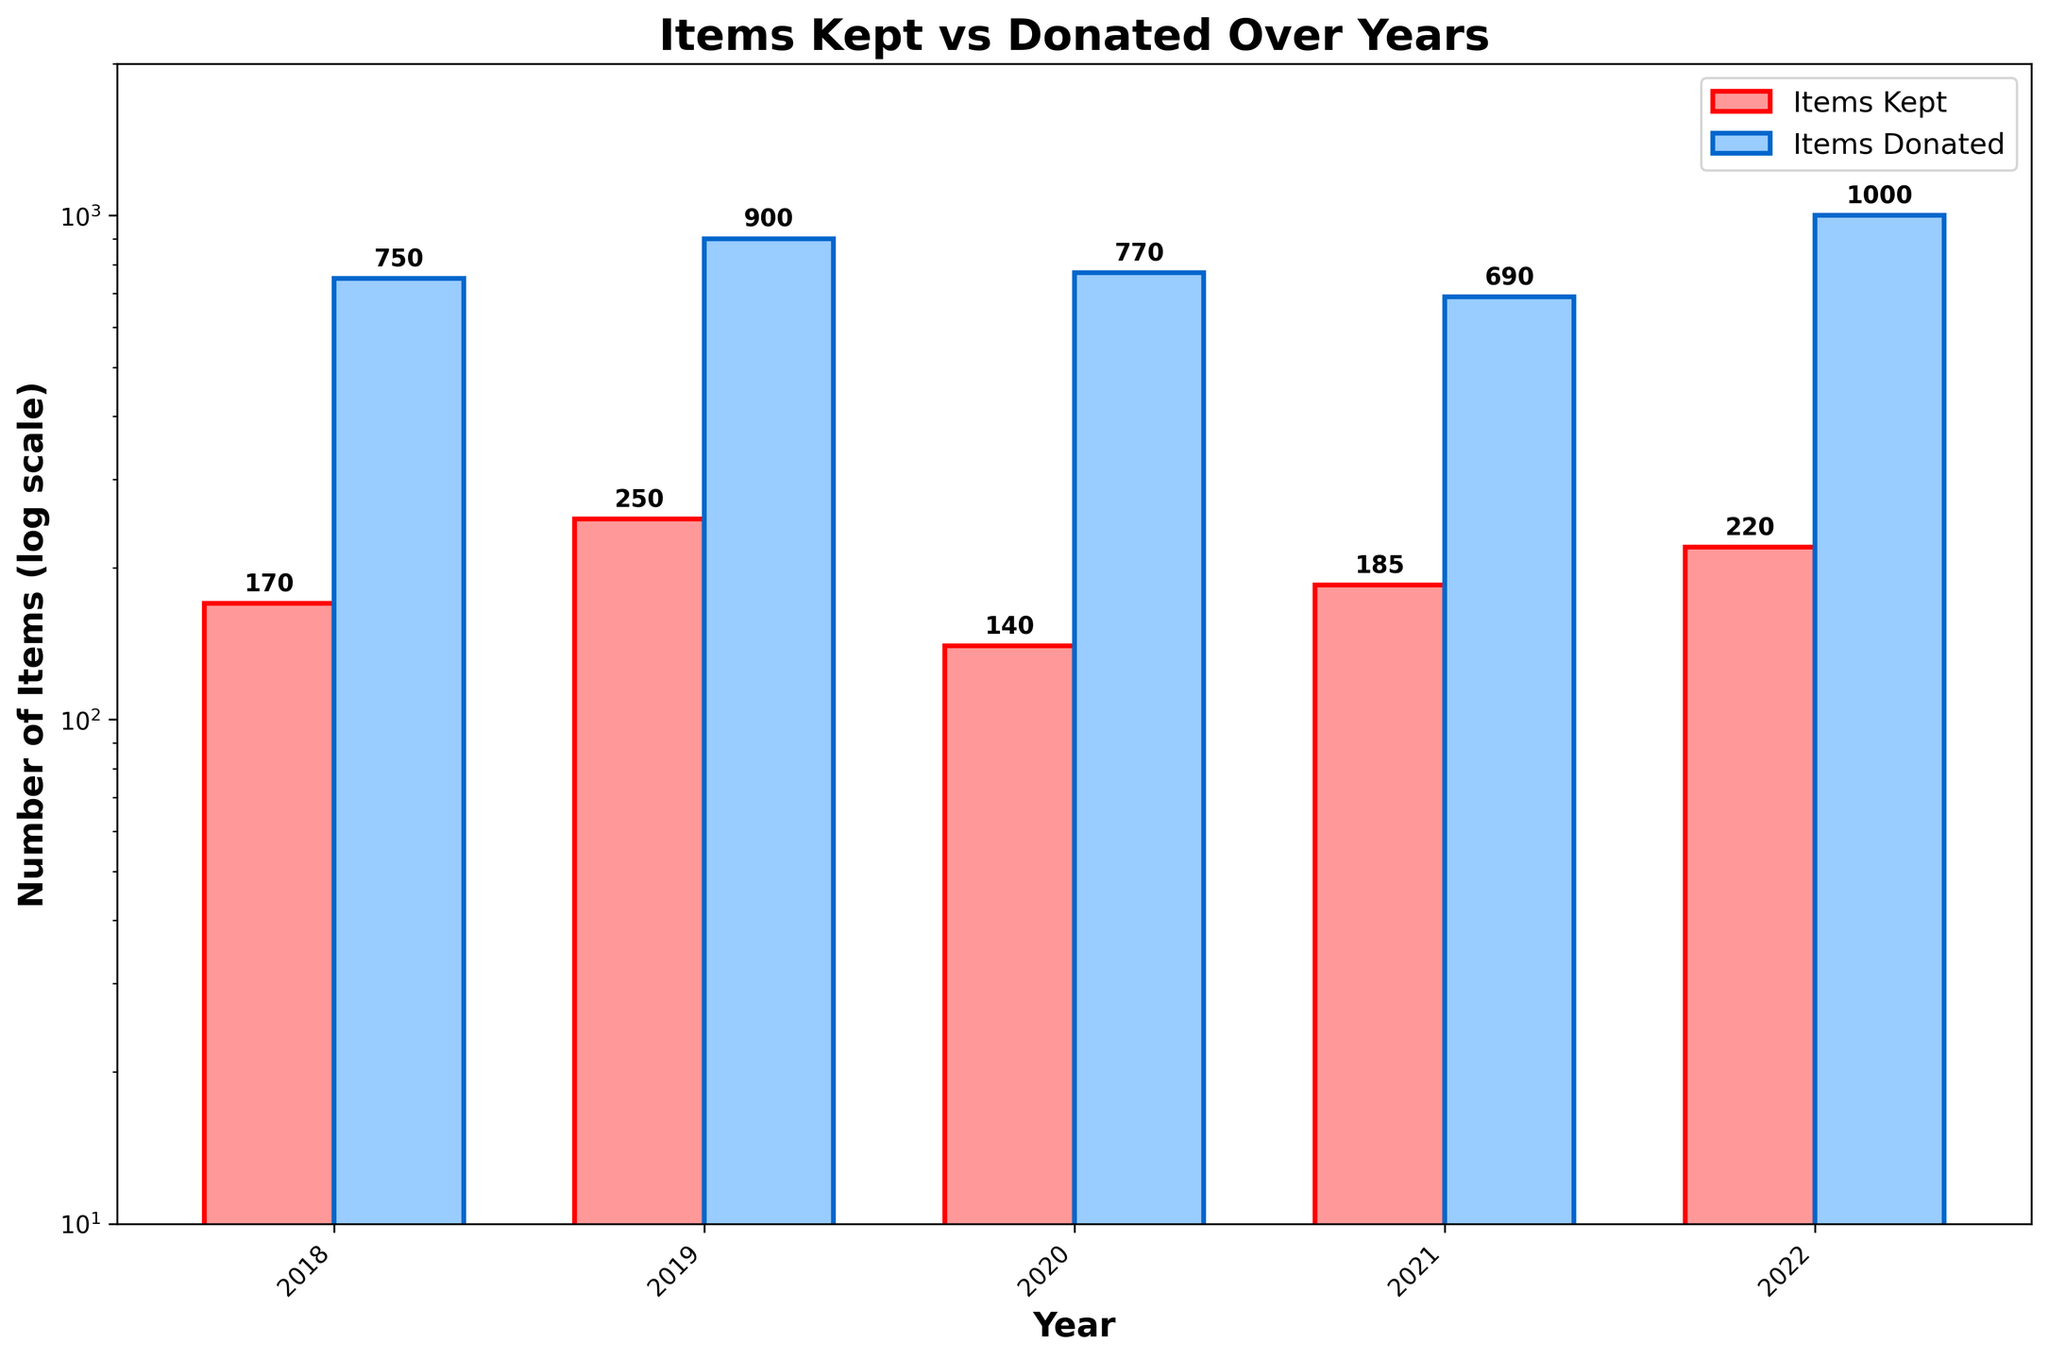What is the title of the figure? The title of the figure is the text at the top of the plot. It usually provides a brief description of what the plot represents.
Answer: Items Kept vs Donated Over Years How many years are displayed on the x-axis? The x-axis represents the different years in the dataset. By counting the unique labels or ticks on the x-axis, we can determine the number of years displayed.
Answer: 5 What is the total number of items kept in 2019? To find the total number of items kept in 2019, refer to the height of the red bar corresponding to 2019 and find the value labeled.
Answer: 250 Which year had the highest number of items donated? To find the year with the highest number of items donated, identify the tallest blue bar and read the year label on the x-axis below it.
Answer: 2022 What is the difference in the number of items kept between 2018 and 2020? First, find the height of the red bars for 2018 and 2020. In 2018, the number of items kept is 170, and in 2020 it is 140. Subtract the 2020 value from the 2018 value.
Answer: 30 Compare the number of items donated in 2021 to 2020. Which year had more items donated? Check the heights of the blue bars for 2021 and 2020. The numbers are 690 for 2020 and 690 for 2021. Since they are equal, neither year had more items donated.
Answer: Equal What is the average number of items donated per year? Sum the heights of the blue bars for each year and then divide by the number of years (5). The donated items are: 750, 900, 770, 640, 1000. Sum = 4060, dividing by 5 gives 812.
Answer: 812 Calculate the ratio of items kept to items donated in 2022. The number of items kept in 2022 is 220, and the number of items donated is 1000. The ratio of items kept to donated is 220/1000.
Answer: 0.22 How does the number of items kept in 2020 compare to those kept in 2021? Compare the heights of the red bars for 2020 (140) and 2021 (185). Since 140 is less than 185, fewer items were kept in 2020.
Answer: Fewer in 2020 What range is set for the y-axis in this plot? The y-axis range can be determined by looking at the minimum and maximum values shown, along with the label '(log scale)'. The range indicated is from 10 to 2000.
Answer: 10 to 2000 